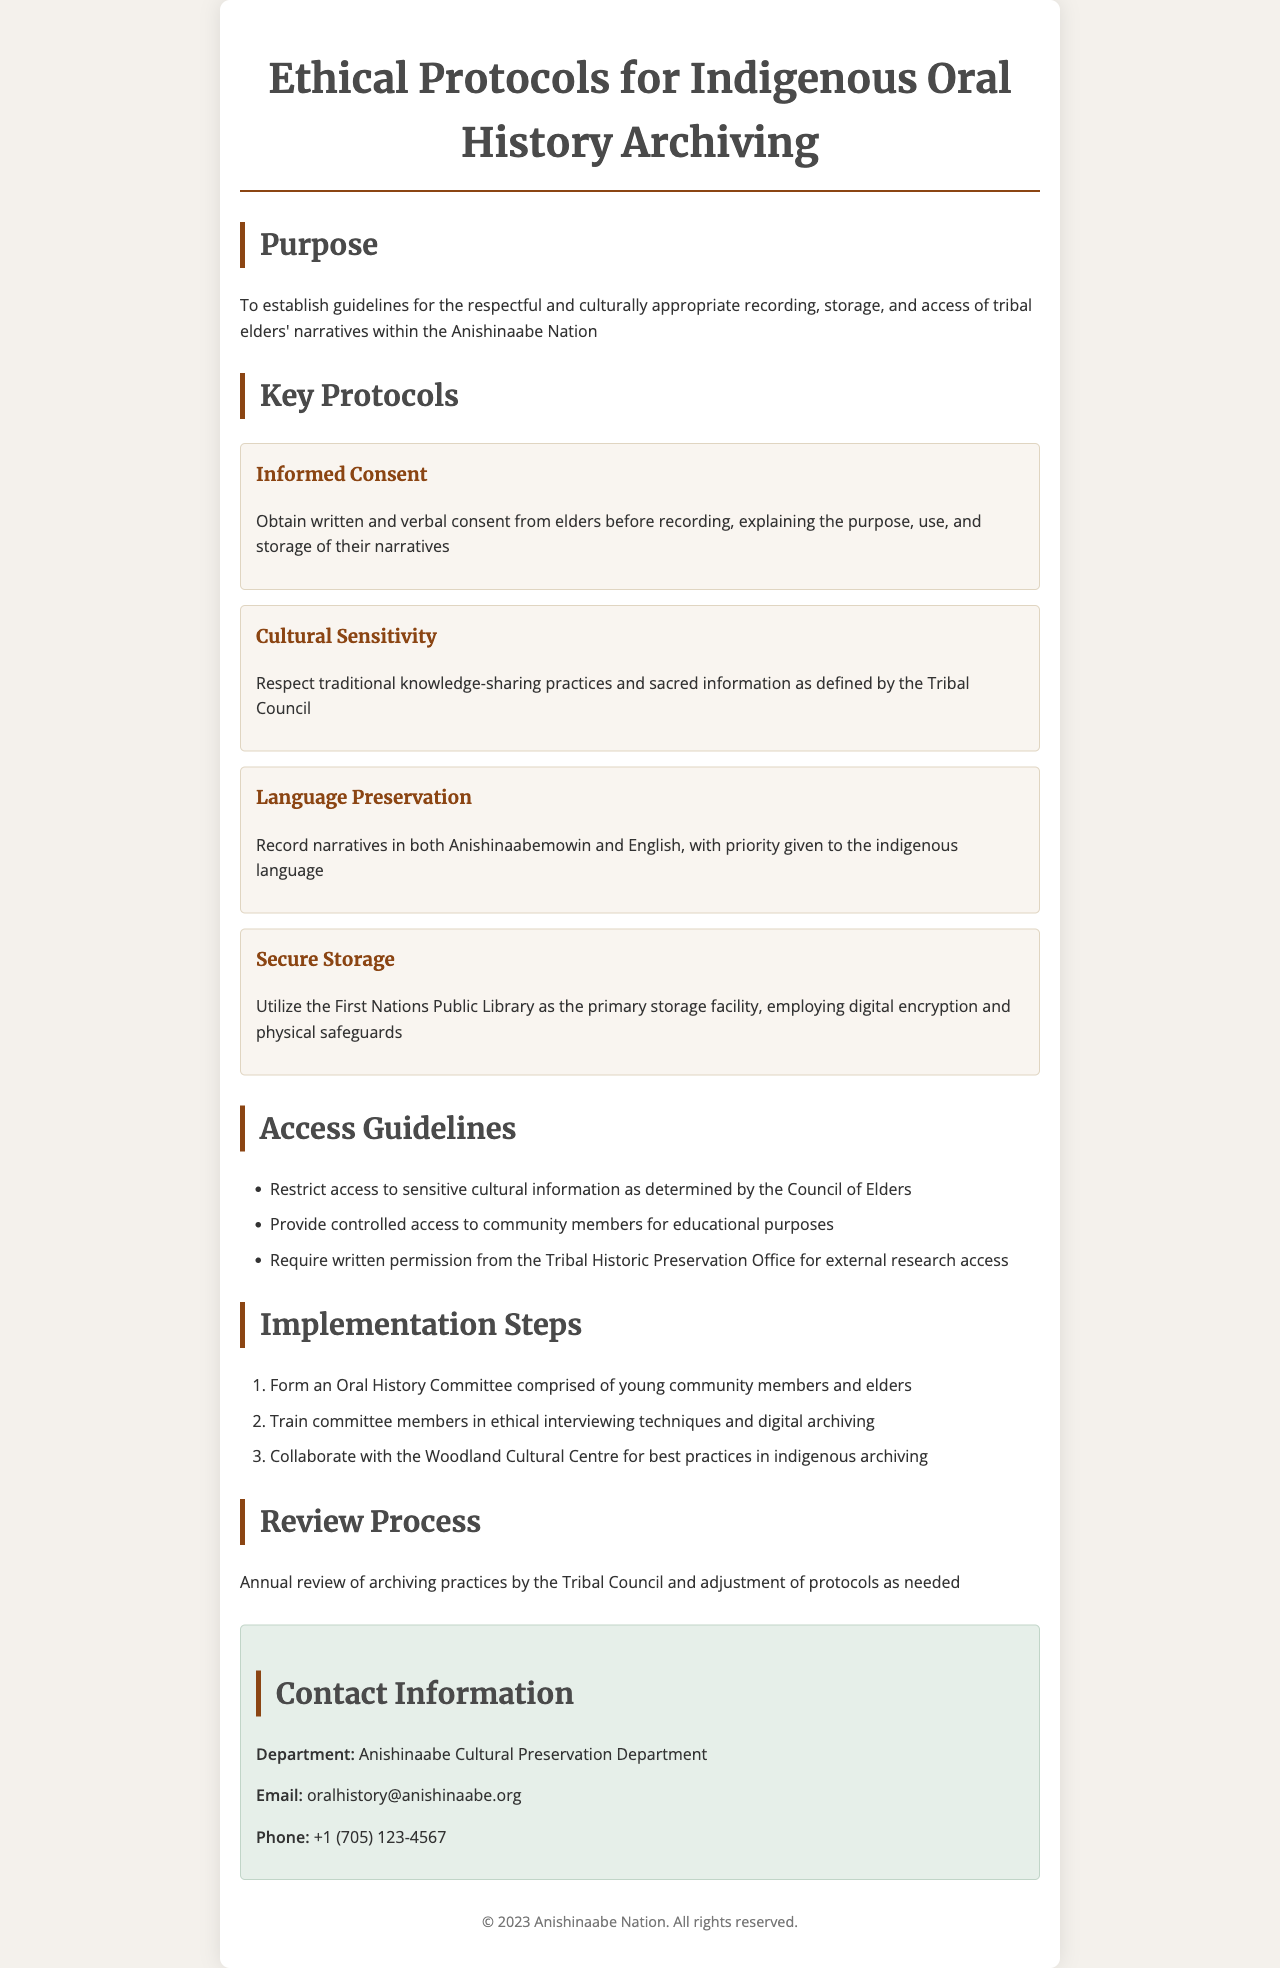What is the purpose of the document? The purpose is to establish guidelines for the respectful and culturally appropriate recording, storage, and access of tribal elders' narratives within the Anishinaabe Nation.
Answer: To establish guidelines for the respectful and culturally appropriate recording, storage, and access of tribal elders' narratives within the Anishinaabe Nation How many key protocols are outlined in the document? The number of key protocols is listed within the "Key Protocols" section of the document.
Answer: Four What should be obtained from elders before recording their narratives? The document specifies a requirement related to consent in the "Informed Consent" section.
Answer: Written and verbal consent Where will the narratives be primarily stored? The primary storage facility is identified within the "Secure Storage" protocol.
Answer: First Nations Public Library What is required for external research access? The document describes the requirement for research access under "Access Guidelines."
Answer: Written permission from the Tribal Historic Preservation Office What is the first step for implementation? The first step is indicated in the "Implementation Steps" section.
Answer: Form an Oral History Committee How often will the archiving practices be reviewed? The review frequency is mentioned in the "Review Process" section of the document.
Answer: Annually What is the email address for the Anishinaabe Cultural Preservation Department? The email address can be found in the "Contact Information" section.
Answer: oralhistory@anishinaabe.org Who is responsible for cultural sensitivity according to the protocols? The responsibility for cultural sensitivity is outlined in the relevant protocol section.
Answer: Tribal Council 